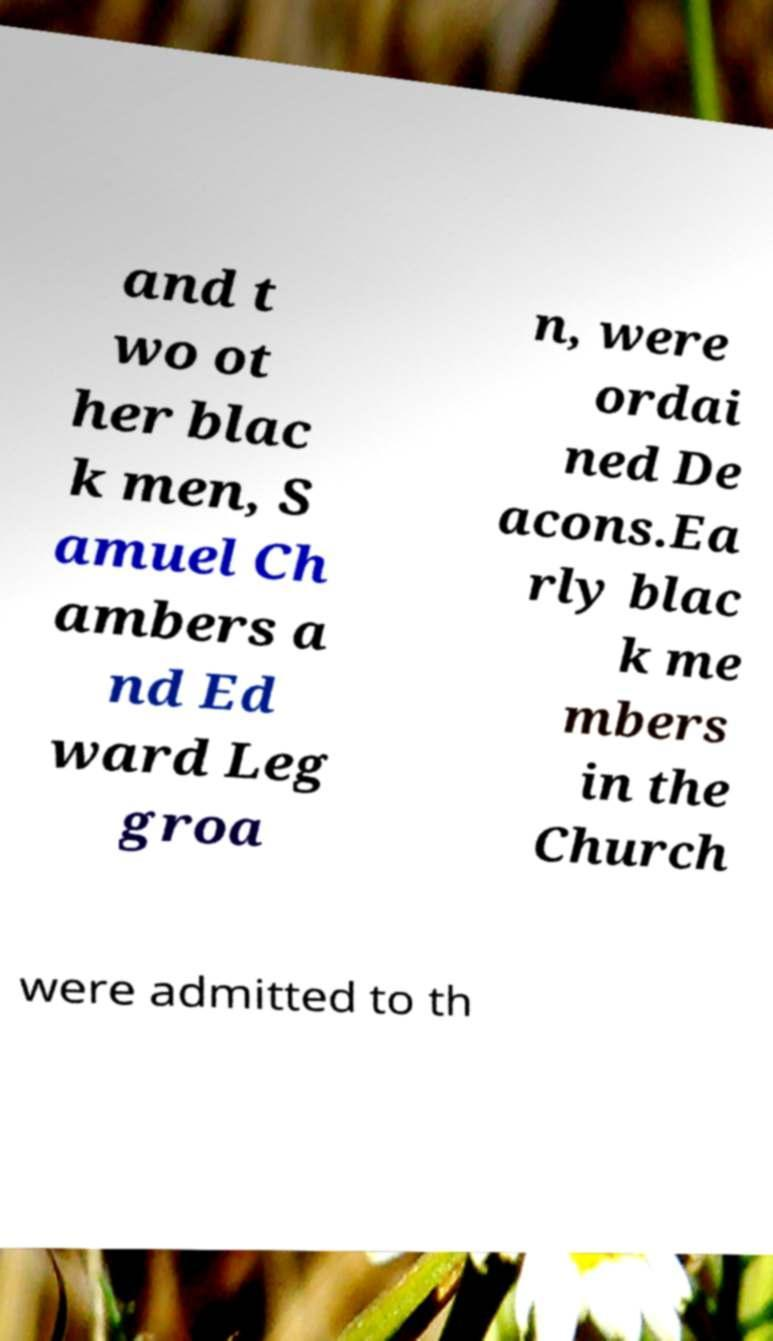Can you read and provide the text displayed in the image?This photo seems to have some interesting text. Can you extract and type it out for me? and t wo ot her blac k men, S amuel Ch ambers a nd Ed ward Leg groa n, were ordai ned De acons.Ea rly blac k me mbers in the Church were admitted to th 